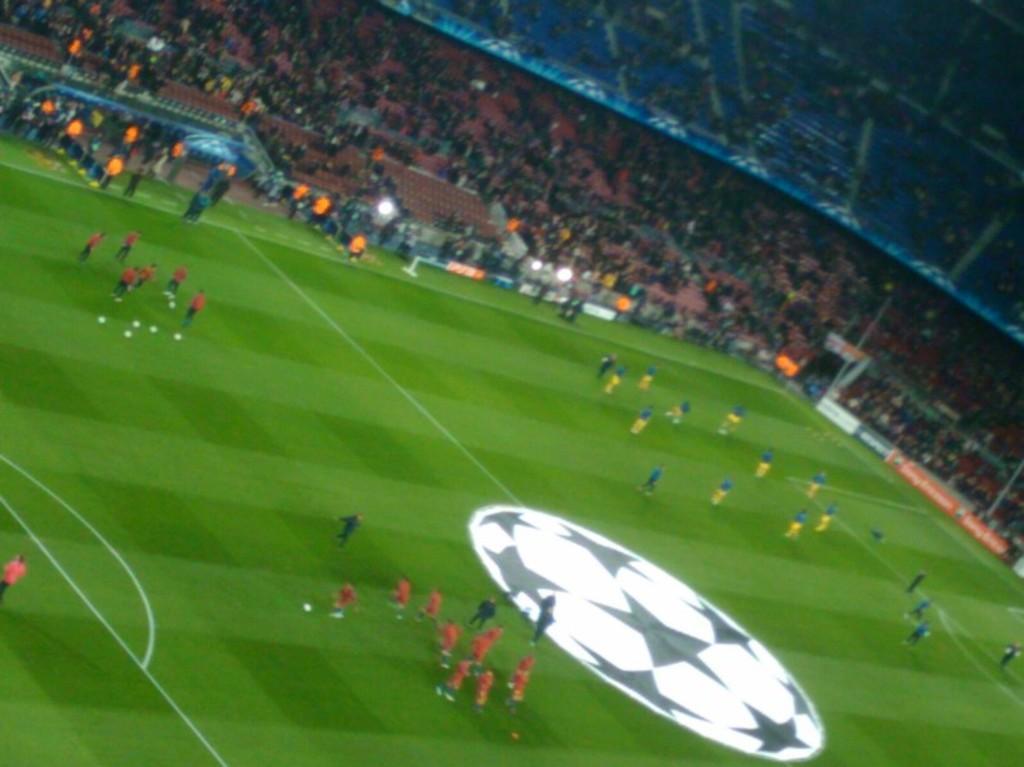Could you give a brief overview of what you see in this image? In this picture we can see the view of the football ground with some players. Behind we can see the audience sitting on the chair and enjoying the game. 